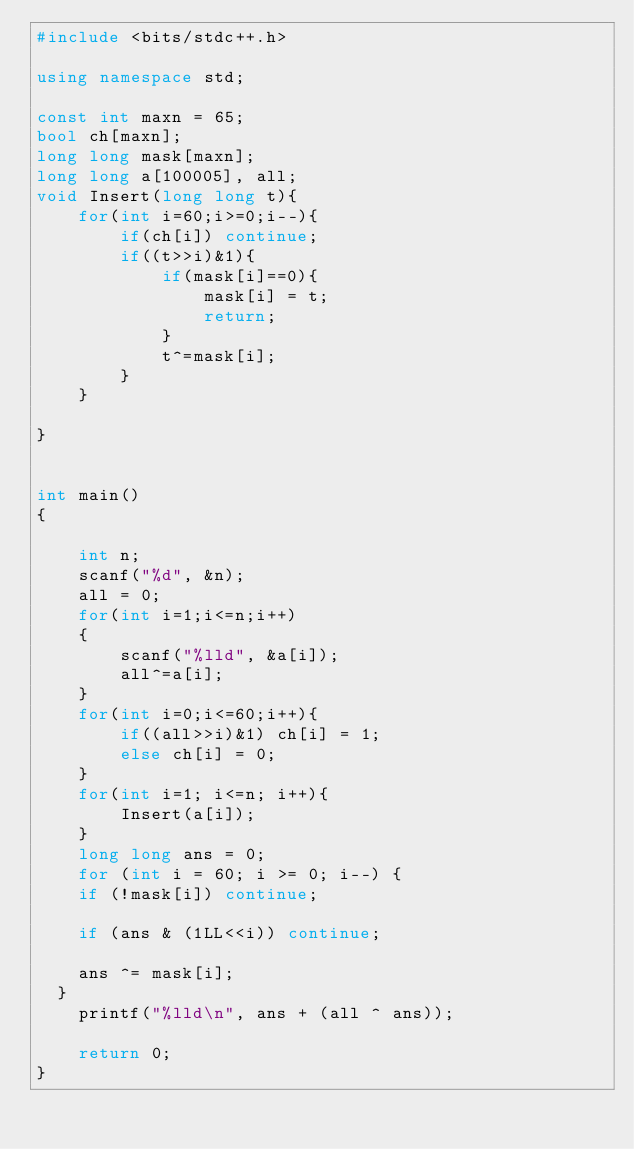<code> <loc_0><loc_0><loc_500><loc_500><_C++_>#include <bits/stdc++.h>

using namespace std;

const int maxn = 65;
bool ch[maxn];
long long mask[maxn];
long long a[100005], all;
void Insert(long long t){
    for(int i=60;i>=0;i--){
        if(ch[i]) continue;
        if((t>>i)&1){
            if(mask[i]==0){
                mask[i] = t;
                return;
            }
            t^=mask[i];
        }
    }

}


int main()
{

    int n;
    scanf("%d", &n);
    all = 0;
    for(int i=1;i<=n;i++)
    {
        scanf("%lld", &a[i]);
        all^=a[i];
    }
    for(int i=0;i<=60;i++){
        if((all>>i)&1) ch[i] = 1;
        else ch[i] = 0;
    }
    for(int i=1; i<=n; i++){
        Insert(a[i]);
    }
    long long ans = 0;
    for (int i = 60; i >= 0; i--) {
		if (!mask[i]) continue;

		if (ans & (1LL<<i)) continue;

		ans ^= mask[i];
	}
    printf("%lld\n", ans + (all ^ ans));

    return 0;
}

</code> 